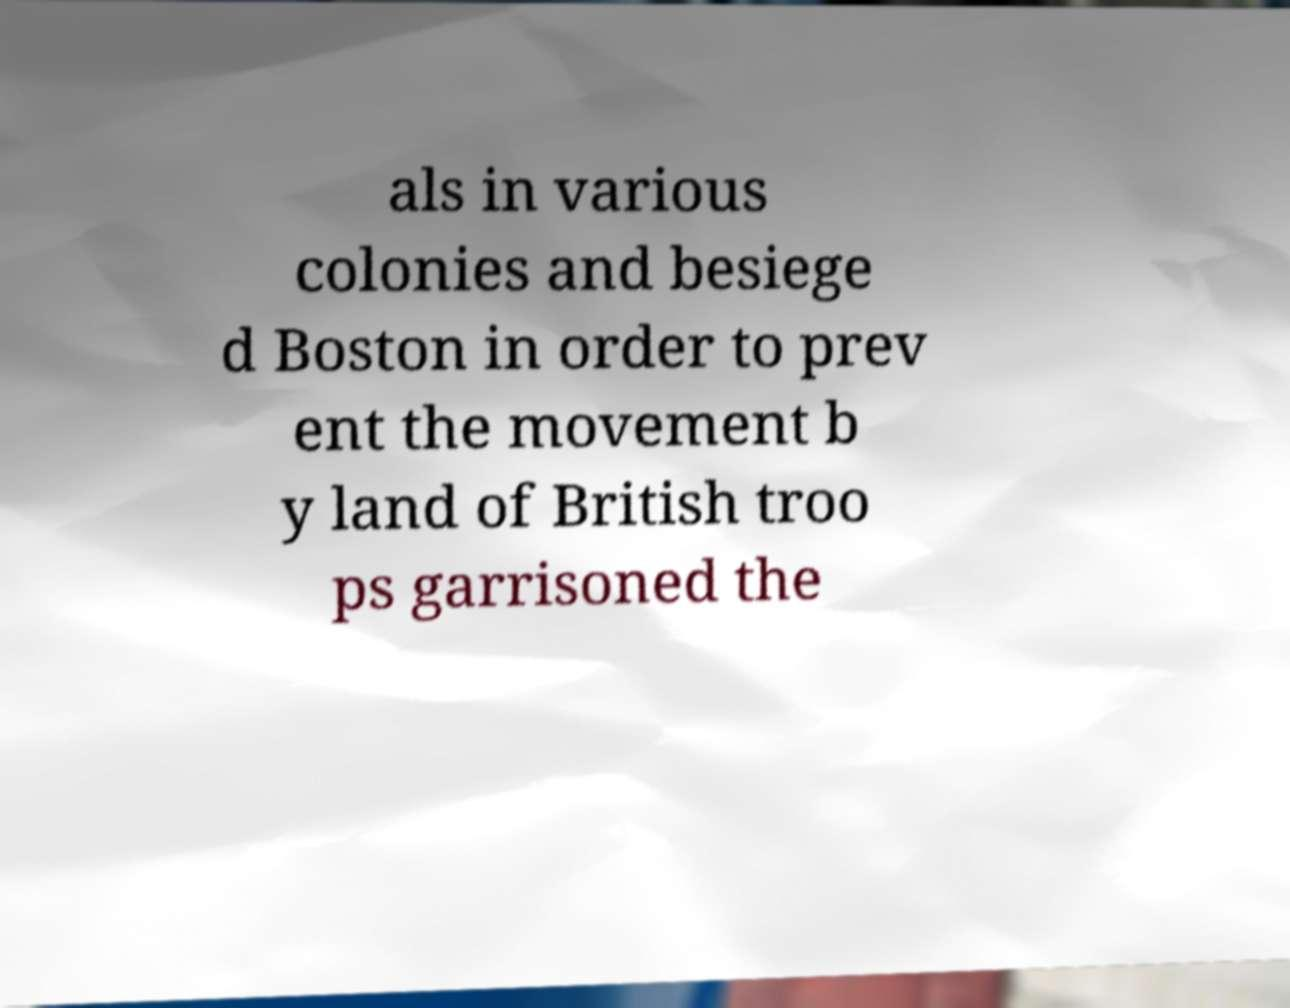Please read and relay the text visible in this image. What does it say? als in various colonies and besiege d Boston in order to prev ent the movement b y land of British troo ps garrisoned the 